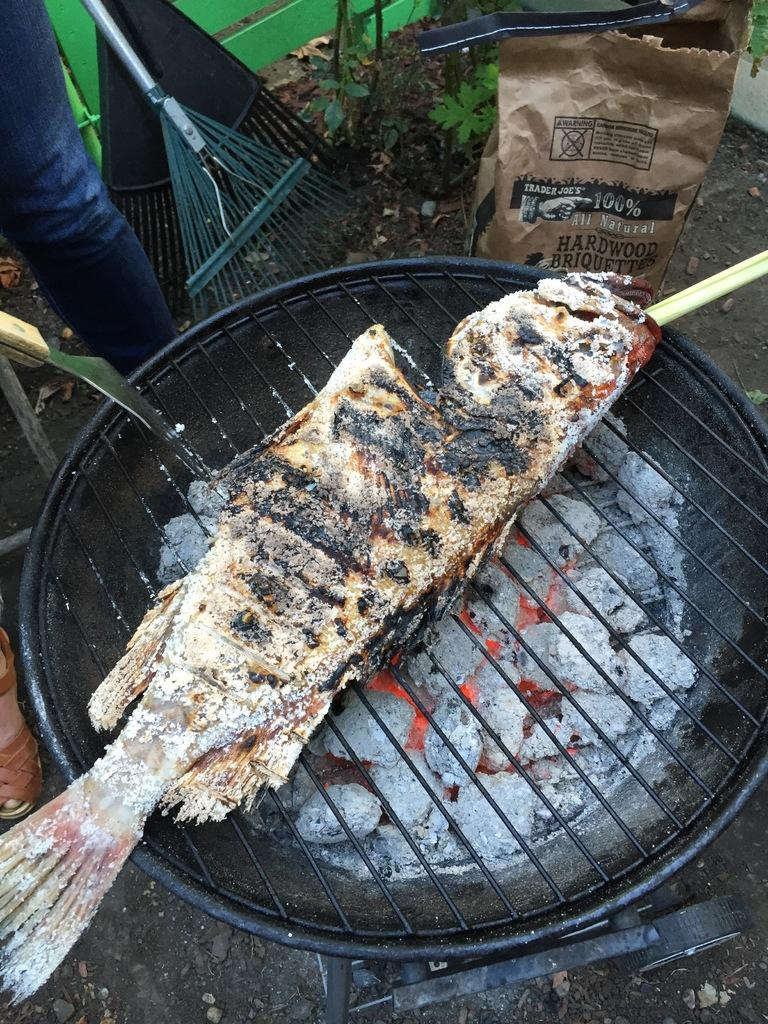What is the person in the image doing? The person is frying fish on a grill pan. What type of cooking equipment is being used by the person? The person is using a grill pan to fry the fish. What else can be seen in the image besides the person and the grill pan? There are objects beside the person. What type of honey is being used to catch the rod in the image? There is no rod or honey present in the image; the person is frying fish on a grill pan. 